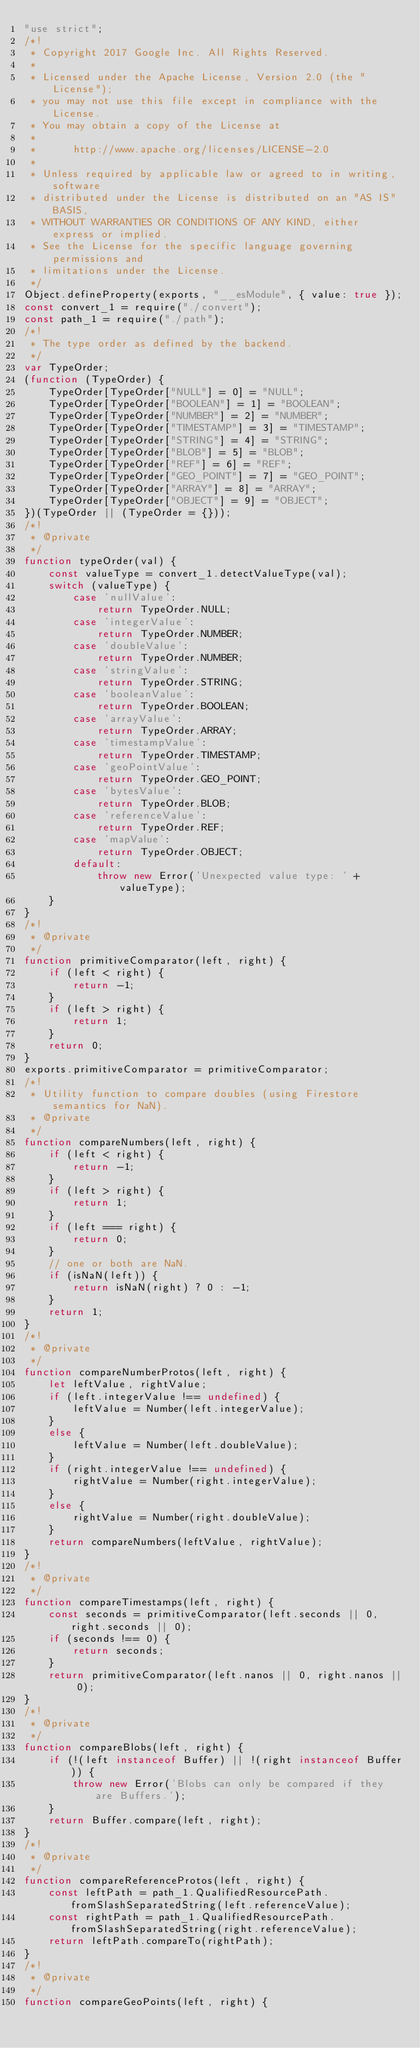Convert code to text. <code><loc_0><loc_0><loc_500><loc_500><_JavaScript_>"use strict";
/*!
 * Copyright 2017 Google Inc. All Rights Reserved.
 *
 * Licensed under the Apache License, Version 2.0 (the "License");
 * you may not use this file except in compliance with the License.
 * You may obtain a copy of the License at
 *
 *      http://www.apache.org/licenses/LICENSE-2.0
 *
 * Unless required by applicable law or agreed to in writing, software
 * distributed under the License is distributed on an "AS IS" BASIS,
 * WITHOUT WARRANTIES OR CONDITIONS OF ANY KIND, either express or implied.
 * See the License for the specific language governing permissions and
 * limitations under the License.
 */
Object.defineProperty(exports, "__esModule", { value: true });
const convert_1 = require("./convert");
const path_1 = require("./path");
/*!
 * The type order as defined by the backend.
 */
var TypeOrder;
(function (TypeOrder) {
    TypeOrder[TypeOrder["NULL"] = 0] = "NULL";
    TypeOrder[TypeOrder["BOOLEAN"] = 1] = "BOOLEAN";
    TypeOrder[TypeOrder["NUMBER"] = 2] = "NUMBER";
    TypeOrder[TypeOrder["TIMESTAMP"] = 3] = "TIMESTAMP";
    TypeOrder[TypeOrder["STRING"] = 4] = "STRING";
    TypeOrder[TypeOrder["BLOB"] = 5] = "BLOB";
    TypeOrder[TypeOrder["REF"] = 6] = "REF";
    TypeOrder[TypeOrder["GEO_POINT"] = 7] = "GEO_POINT";
    TypeOrder[TypeOrder["ARRAY"] = 8] = "ARRAY";
    TypeOrder[TypeOrder["OBJECT"] = 9] = "OBJECT";
})(TypeOrder || (TypeOrder = {}));
/*!
 * @private
 */
function typeOrder(val) {
    const valueType = convert_1.detectValueType(val);
    switch (valueType) {
        case 'nullValue':
            return TypeOrder.NULL;
        case 'integerValue':
            return TypeOrder.NUMBER;
        case 'doubleValue':
            return TypeOrder.NUMBER;
        case 'stringValue':
            return TypeOrder.STRING;
        case 'booleanValue':
            return TypeOrder.BOOLEAN;
        case 'arrayValue':
            return TypeOrder.ARRAY;
        case 'timestampValue':
            return TypeOrder.TIMESTAMP;
        case 'geoPointValue':
            return TypeOrder.GEO_POINT;
        case 'bytesValue':
            return TypeOrder.BLOB;
        case 'referenceValue':
            return TypeOrder.REF;
        case 'mapValue':
            return TypeOrder.OBJECT;
        default:
            throw new Error('Unexpected value type: ' + valueType);
    }
}
/*!
 * @private
 */
function primitiveComparator(left, right) {
    if (left < right) {
        return -1;
    }
    if (left > right) {
        return 1;
    }
    return 0;
}
exports.primitiveComparator = primitiveComparator;
/*!
 * Utility function to compare doubles (using Firestore semantics for NaN).
 * @private
 */
function compareNumbers(left, right) {
    if (left < right) {
        return -1;
    }
    if (left > right) {
        return 1;
    }
    if (left === right) {
        return 0;
    }
    // one or both are NaN.
    if (isNaN(left)) {
        return isNaN(right) ? 0 : -1;
    }
    return 1;
}
/*!
 * @private
 */
function compareNumberProtos(left, right) {
    let leftValue, rightValue;
    if (left.integerValue !== undefined) {
        leftValue = Number(left.integerValue);
    }
    else {
        leftValue = Number(left.doubleValue);
    }
    if (right.integerValue !== undefined) {
        rightValue = Number(right.integerValue);
    }
    else {
        rightValue = Number(right.doubleValue);
    }
    return compareNumbers(leftValue, rightValue);
}
/*!
 * @private
 */
function compareTimestamps(left, right) {
    const seconds = primitiveComparator(left.seconds || 0, right.seconds || 0);
    if (seconds !== 0) {
        return seconds;
    }
    return primitiveComparator(left.nanos || 0, right.nanos || 0);
}
/*!
 * @private
 */
function compareBlobs(left, right) {
    if (!(left instanceof Buffer) || !(right instanceof Buffer)) {
        throw new Error('Blobs can only be compared if they are Buffers.');
    }
    return Buffer.compare(left, right);
}
/*!
 * @private
 */
function compareReferenceProtos(left, right) {
    const leftPath = path_1.QualifiedResourcePath.fromSlashSeparatedString(left.referenceValue);
    const rightPath = path_1.QualifiedResourcePath.fromSlashSeparatedString(right.referenceValue);
    return leftPath.compareTo(rightPath);
}
/*!
 * @private
 */
function compareGeoPoints(left, right) {</code> 